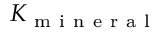Convert formula to latex. <formula><loc_0><loc_0><loc_500><loc_500>K _ { m i n e r a l }</formula> 